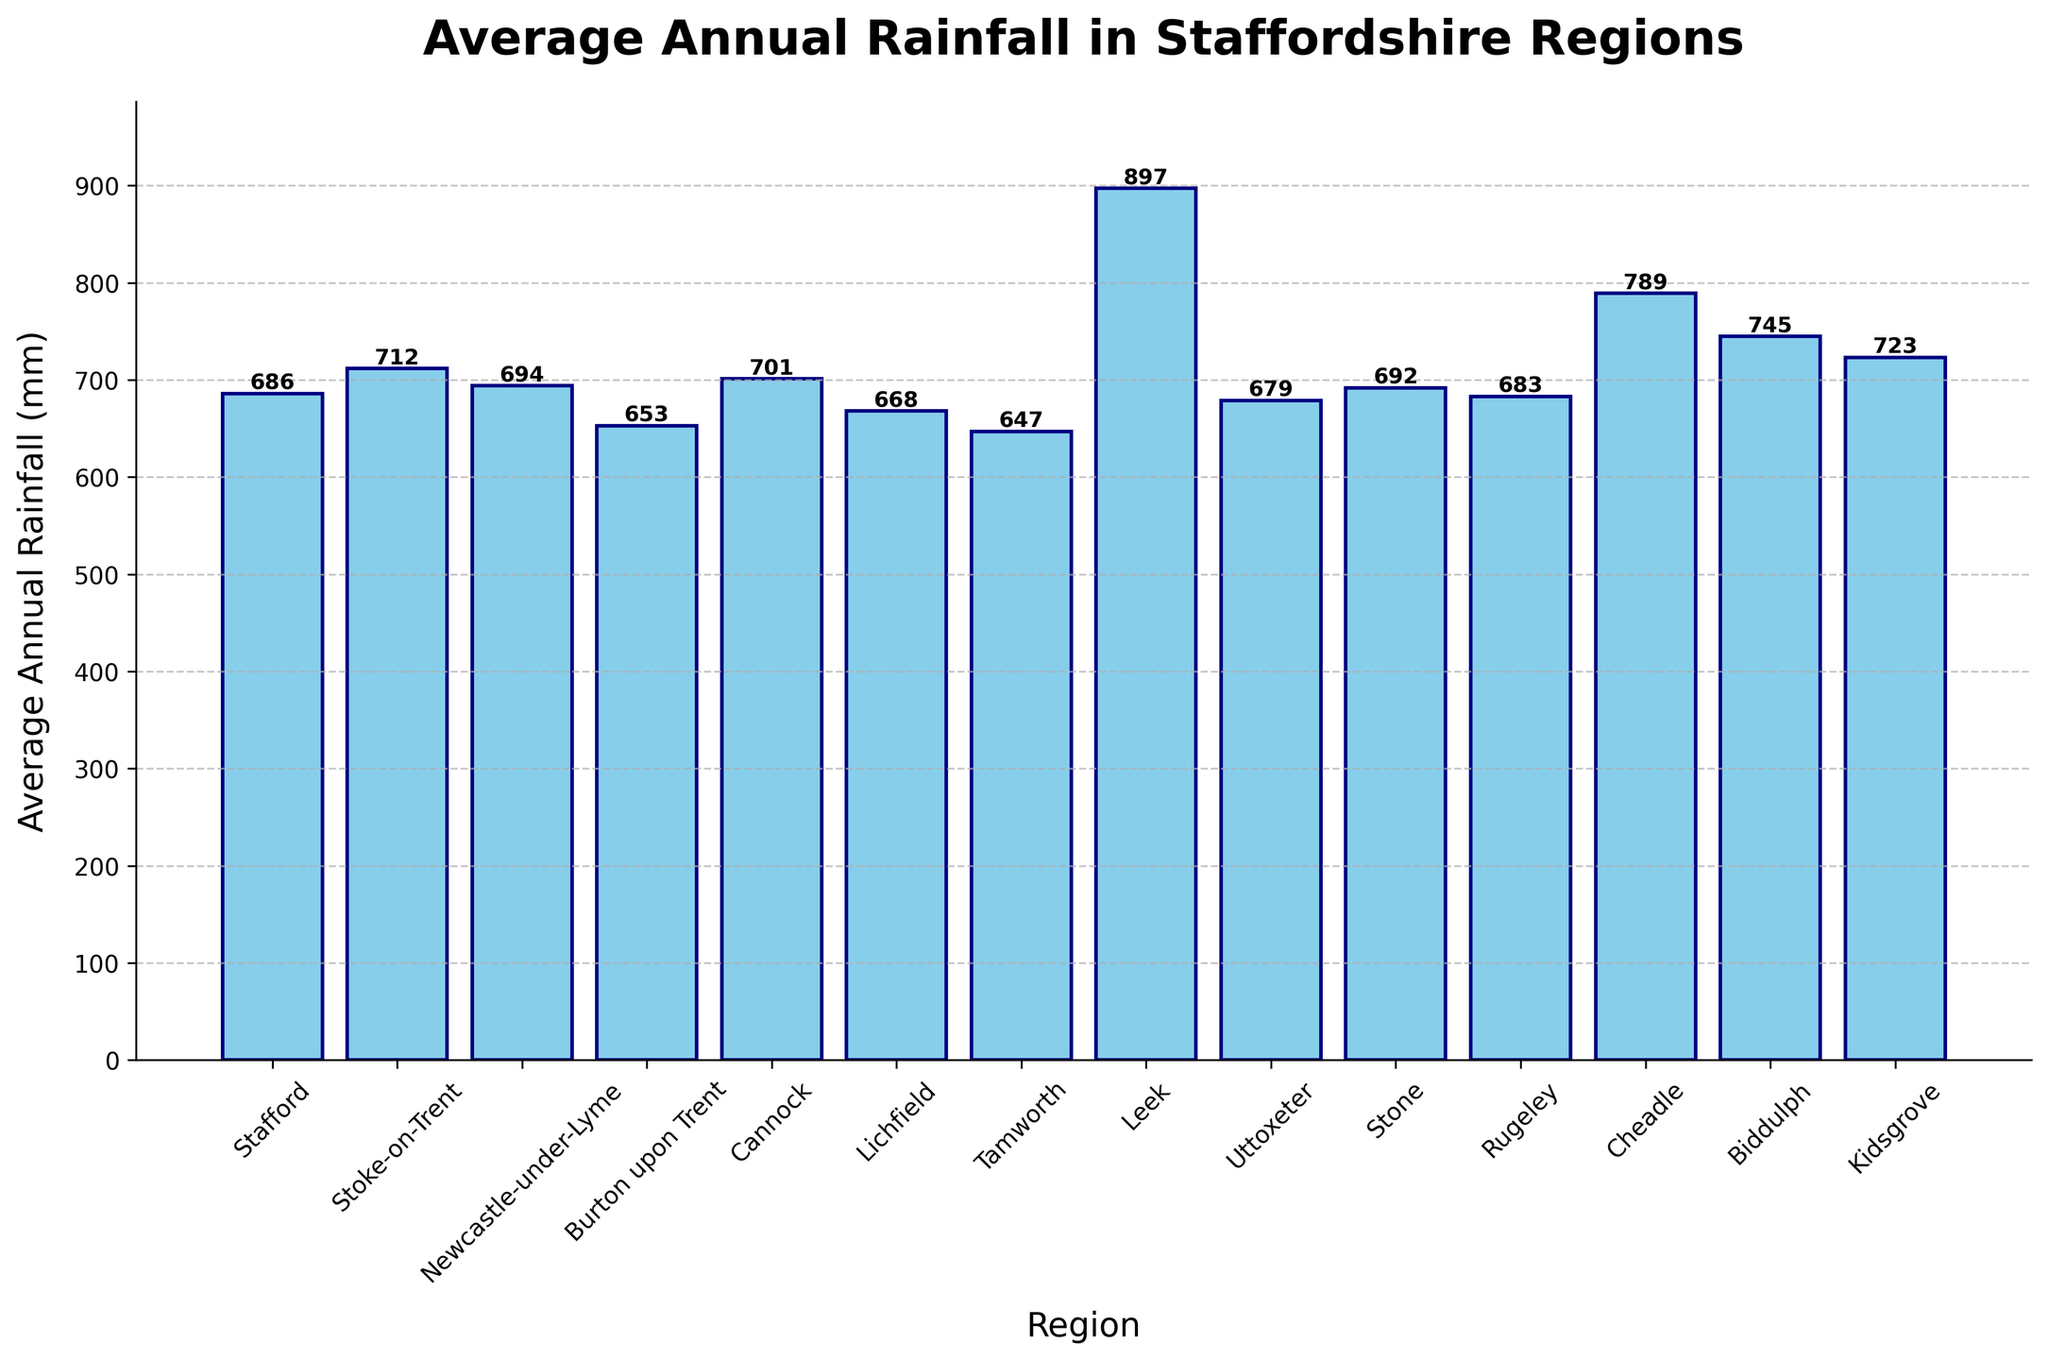Which region received the most average annual rainfall? The region with the tallest bar represents the highest average annual rainfall. Leek has the tallest bar.
Answer: Leek Which region received the least average annual rainfall? The region with the shortest bar represents the lowest average annual rainfall. Tamworth has the shortest bar.
Answer: Tamworth What is the difference in average annual rainfall between Stoke-on-Trent and Cheadle? Identify Stoke-on-Trent and Cheadle on the x-axis. Stoke-on-Trent: 712 mm, Cheadle: 789 mm. Calculate the difference: 789 - 712 = 77 mm.
Answer: 77 mm What is the total average annual rainfall for Stafford and Newcastle-under-Lyme combined? Identify Stafford and Newcastle-under-Lyme on the x-axis. Stafford: 686 mm, Newcastle-under-Lyme: 694 mm. Sum these values: 686 + 694 = 1380 mm.
Answer: 1380 mm Which regions have an average annual rainfall greater than 700 mm? Look for bars exceeding the 700 mm mark on the y-axis: Stoke-on-Trent, Cannock, Leek, Cheadle, Biddulph, Kidsgrove.
Answer: Stoke-on-Trent, Cannock, Leek, Cheadle, Biddulph, Kidsgrove How does the average annual rainfall in Uttoxeter compare to that in Stone? Compare the heights of the bars for Uttoxeter and Stone. Uttoxeter: 679 mm, Stone: 692 mm, Stone's rainfall is higher.
Answer: Stone's is higher What is the median average annual rainfall of all regions? Arrange the rainfalls in ascending order: 647, 653, 668, 679, 683, 686, 692, 694, 701, 712, 723, 745, 789, 897. Median of 14 values is the average of the 7th and 8th: (692+694)/2 = 693 mm.
Answer: 693 mm Which region shows exactly 745 mm of average annual rainfall? Scan the y-axis for the 745 mm mark and find the corresponding bar, which is Biddulph.
Answer: Biddulph What percentage of regions have an average annual rainfall less than 700 mm? Identify which regions have less than 700 mm (7 regions): Stafford, Burton upon Trent, Lichfield, Tamworth, Uttoxeter, Stone, Rugeley. Total regions: 14. Calculate the percentage: (7/14)*100 = 50%.
Answer: 50% What's the average annual rainfall across all Staffordshire regions? Sum up all rainfall values: 686 + 712 + 694 + 653 + 701 + 668 + 647 + 897 + 679 + 692 + 683 + 789 + 745 + 723 = 9869 mm. Divide by the number of regions (14): 9869/14 ≈ 704.93 mm.
Answer: 704.93 mm 